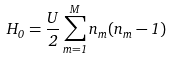Convert formula to latex. <formula><loc_0><loc_0><loc_500><loc_500>H _ { 0 } = \frac { U } { 2 } \sum _ { m = 1 } ^ { M } n _ { m } ( n _ { m } - 1 )</formula> 